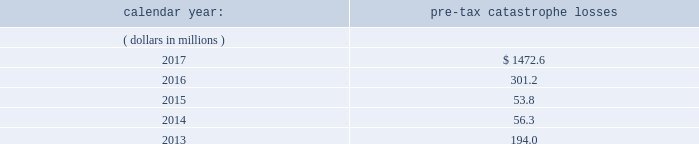Item 1a .
Risk factors in addition to the other information provided in this report , the following risk factors should be considered when evaluating an investment in our securities .
If the circumstances contemplated by the individual risk factors materialize , our business , financial condition and results of operations could be materially and adversely affected and the trading price of our common shares could decline significantly .
Risks relating to our business fluctuations in the financial markets could result in investment losses .
Prolonged and severe disruptions in the overall public debt and equity markets , such as occurred during 2008 , could result in significant realized and unrealized losses in our investment portfolio .
Although financial markets have significantly improved since 2008 , they could deteriorate in the future .
There could also be disruption in individual market sectors , such as occurred in the energy sector in recent years .
Such declines in the financial markets could result in significant realized and unrealized losses on investments and could have a material adverse impact on our results of operations , equity , business and insurer financial strength and debt ratings .
Our results could be adversely affected by catastrophic events .
We are exposed to unpredictable catastrophic events , including weather-related and other natural catastrophes , as well as acts of terrorism .
Any material reduction in our operating results caused by the occurrence of one or more catastrophes could inhibit our ability to pay dividends or to meet our interest and principal payment obligations .
By way of illustration , during the past five calendar years , pre-tax catastrophe losses , net of reinsurance , were as follows: .
Our losses from future catastrophic events could exceed our projections .
We use projections of possible losses from future catastrophic events of varying types and magnitudes as a strategic underwriting tool .
We use these loss projections to estimate our potential catastrophe losses in certain geographic areas and decide on the placement of retrocessional coverage or other actions to limit the extent of potential losses in a given geographic area .
These loss projections are approximations , reliant on a mix of quantitative and qualitative processes , and actual losses may exceed the projections by a material amount , resulting in a material adverse effect on our financial condition and results of operations. .
What are the total pre-tax catastrophe losses for the company in the last two years?\\n? 
Computations: (1472.6 + 301.2)
Answer: 1773.8. 